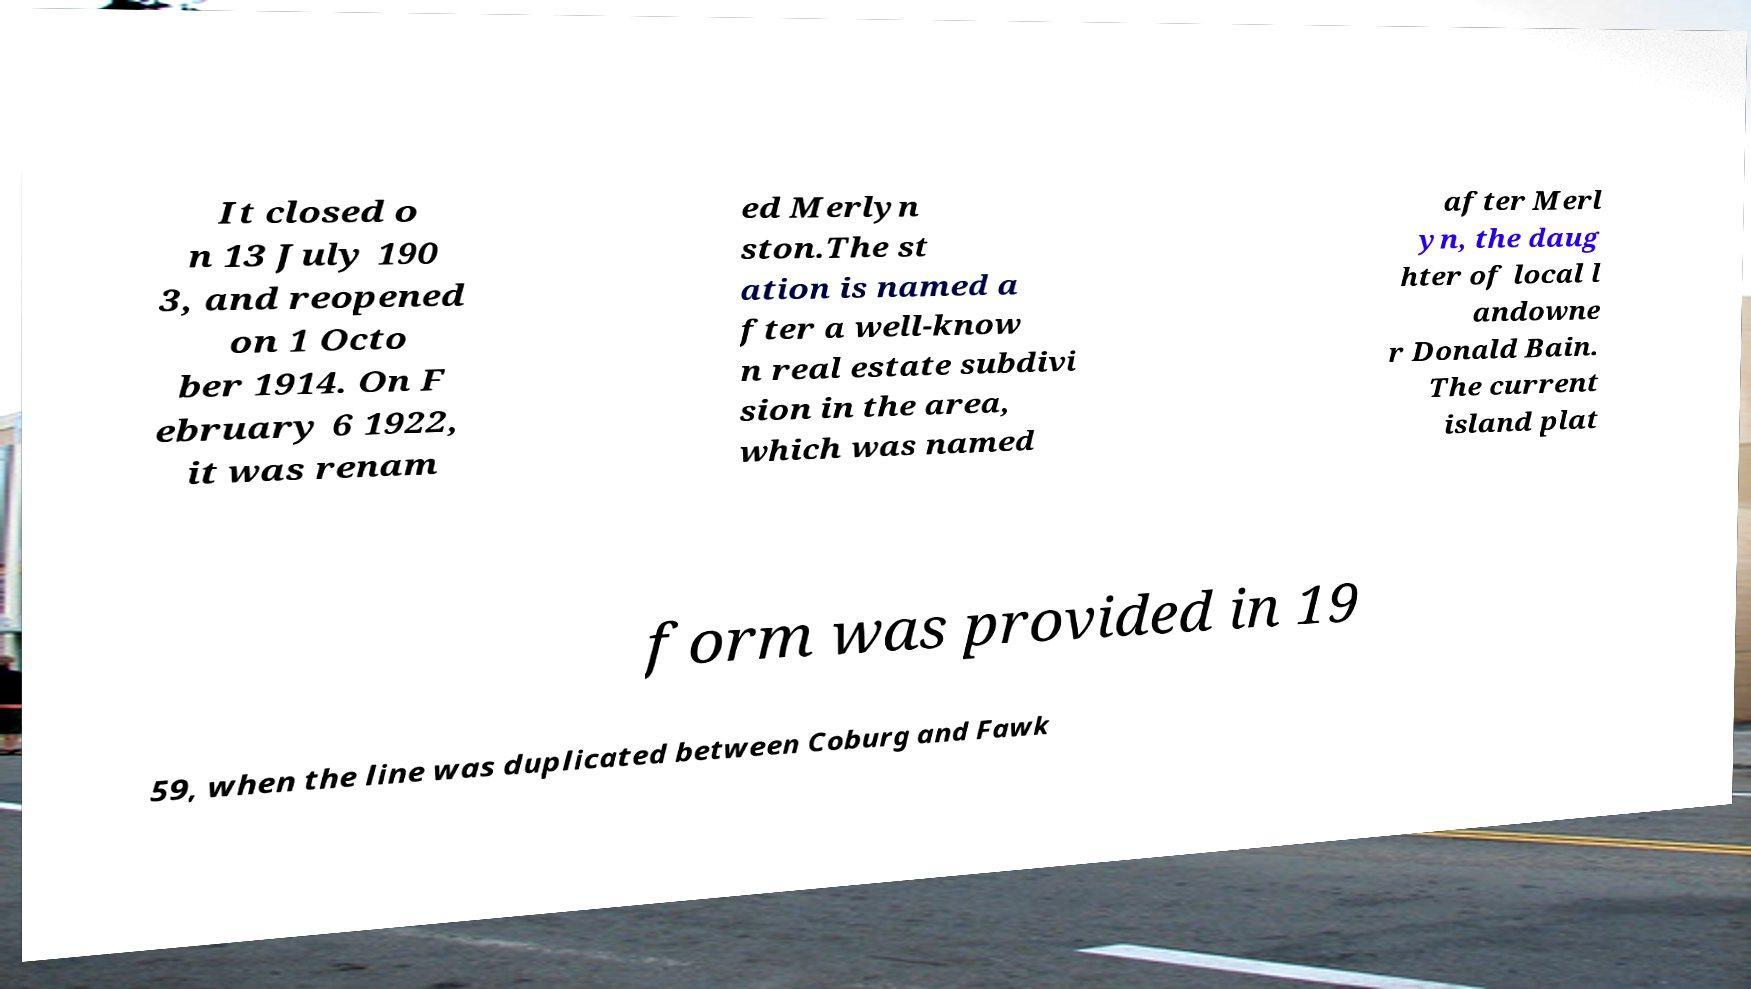I need the written content from this picture converted into text. Can you do that? It closed o n 13 July 190 3, and reopened on 1 Octo ber 1914. On F ebruary 6 1922, it was renam ed Merlyn ston.The st ation is named a fter a well-know n real estate subdivi sion in the area, which was named after Merl yn, the daug hter of local l andowne r Donald Bain. The current island plat form was provided in 19 59, when the line was duplicated between Coburg and Fawk 